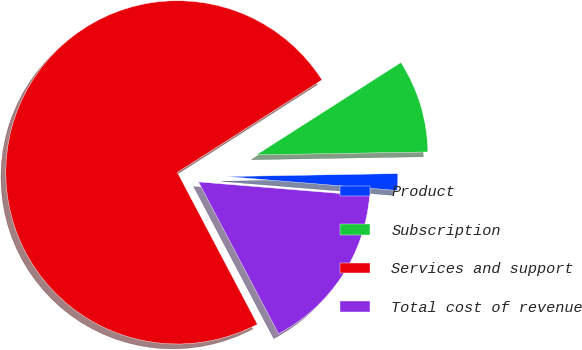<chart> <loc_0><loc_0><loc_500><loc_500><pie_chart><fcel>Product<fcel>Subscription<fcel>Services and support<fcel>Total cost of revenue<nl><fcel>1.57%<fcel>8.78%<fcel>73.67%<fcel>15.99%<nl></chart> 